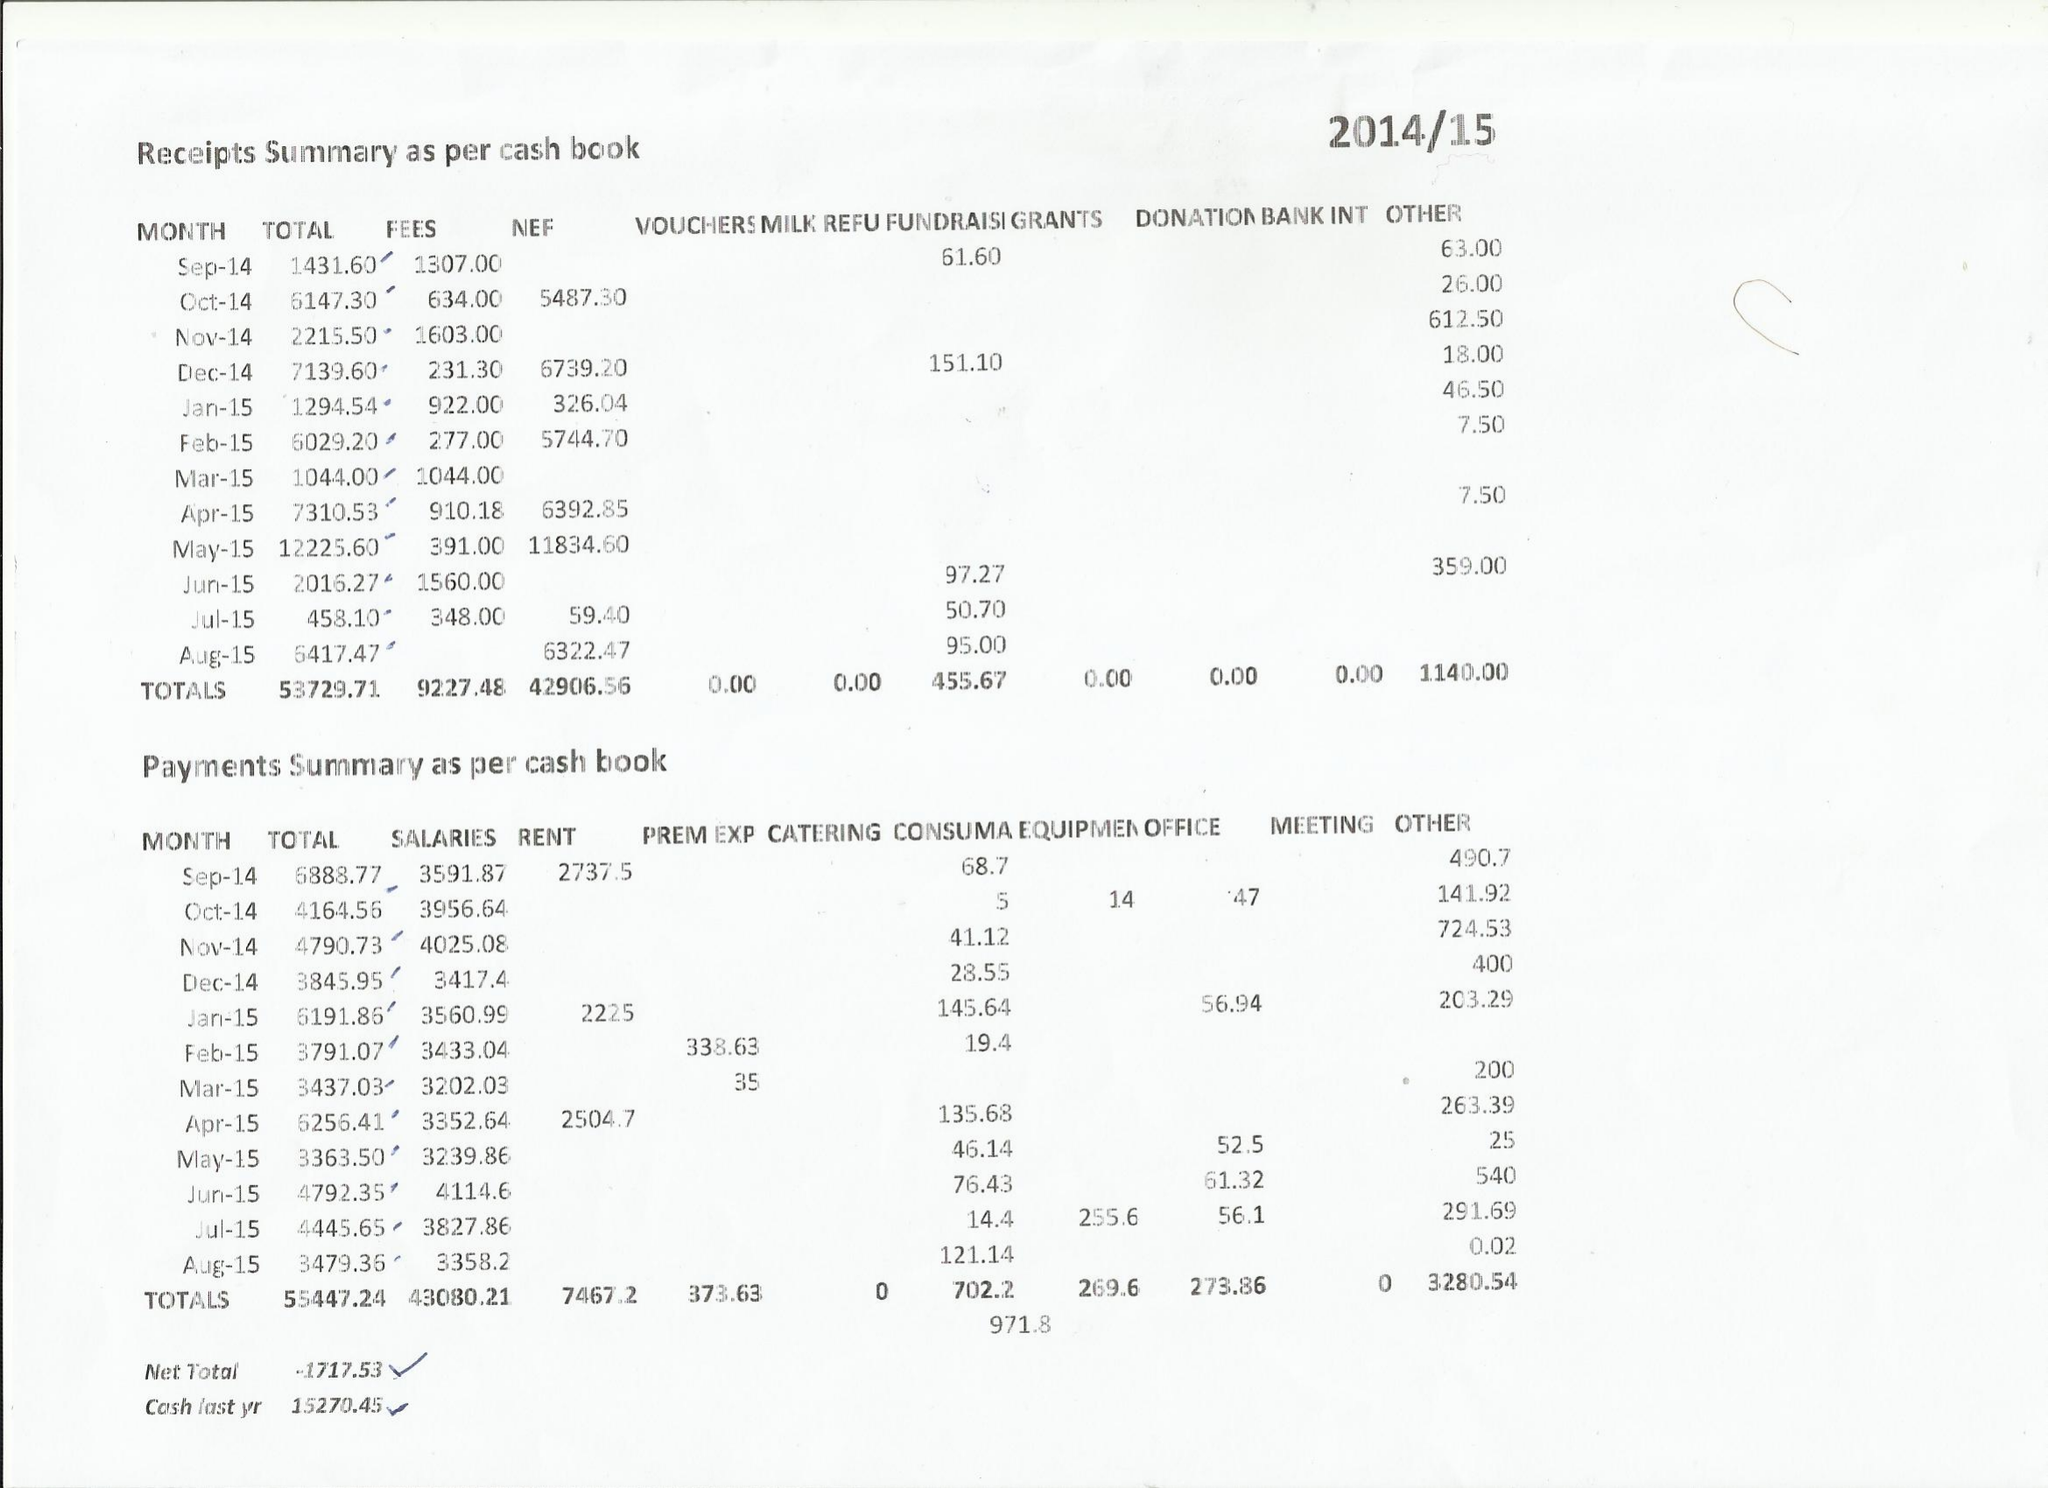What is the value for the address__post_town?
Answer the question using a single word or phrase. MAIDSTONE 